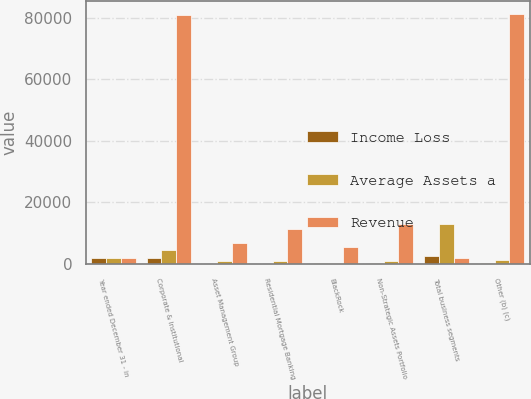<chart> <loc_0><loc_0><loc_500><loc_500><stacked_bar_chart><ecel><fcel>Year ended December 31 - in<fcel>Corporate & Institutional<fcel>Asset Management Group<fcel>Residential Mortgage Banking<fcel>BlackRock<fcel>Non-Strategic Assets Portfolio<fcel>Total business segments<fcel>Other (b) (c)<nl><fcel>Income Loss<fcel>2011<fcel>1875<fcel>141<fcel>87<fcel>361<fcel>200<fcel>2695<fcel>376<nl><fcel>Average Assets a<fcel>2011<fcel>4669<fcel>887<fcel>948<fcel>464<fcel>960<fcel>12970<fcel>1356<nl><fcel>Revenue<fcel>2011<fcel>81043<fcel>6719<fcel>11270<fcel>5516<fcel>13119<fcel>2011<fcel>81220<nl></chart> 